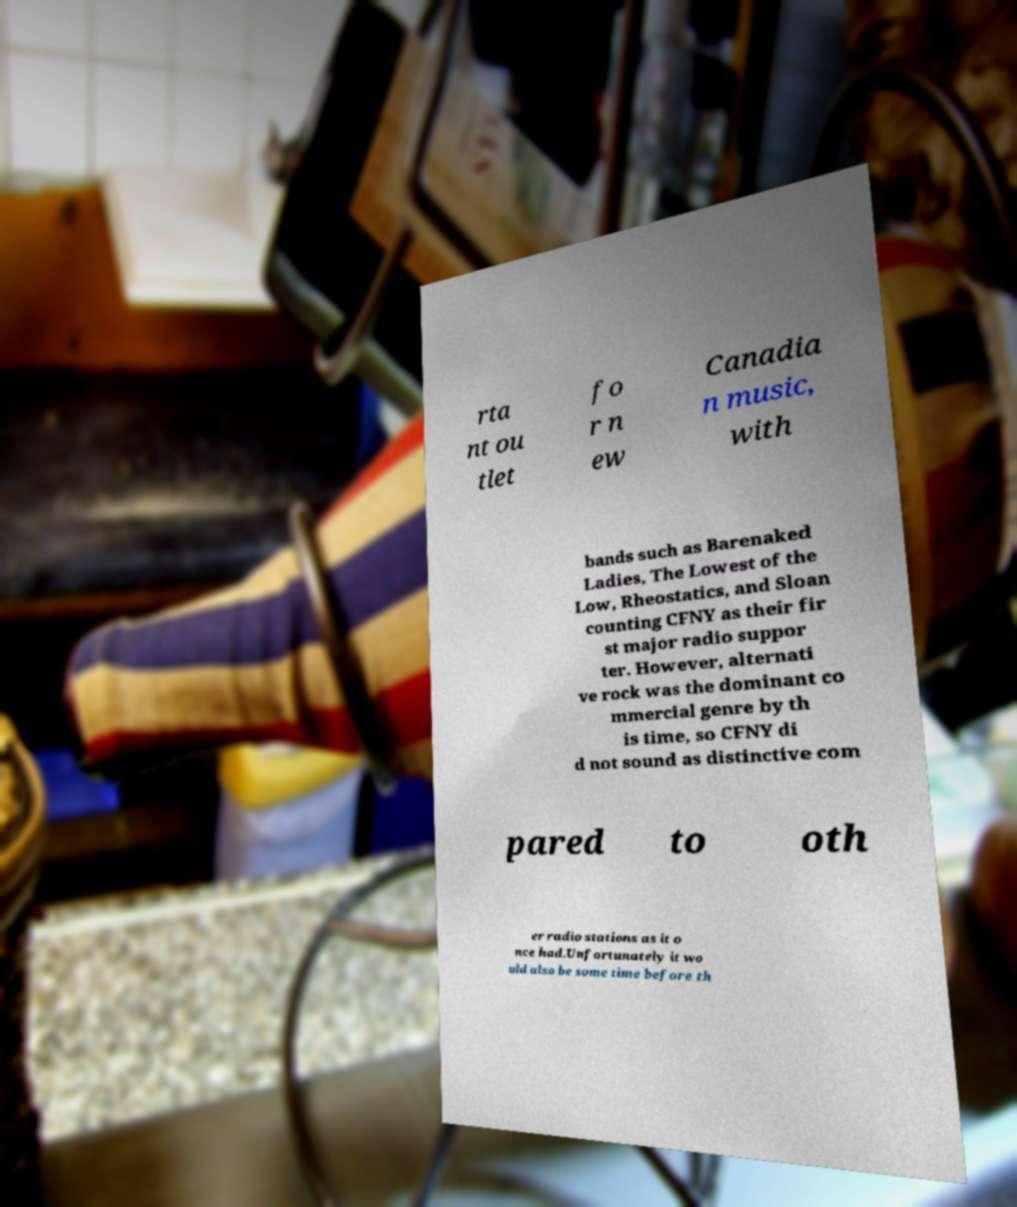Could you extract and type out the text from this image? rta nt ou tlet fo r n ew Canadia n music, with bands such as Barenaked Ladies, The Lowest of the Low, Rheostatics, and Sloan counting CFNY as their fir st major radio suppor ter. However, alternati ve rock was the dominant co mmercial genre by th is time, so CFNY di d not sound as distinctive com pared to oth er radio stations as it o nce had.Unfortunately it wo uld also be some time before th 